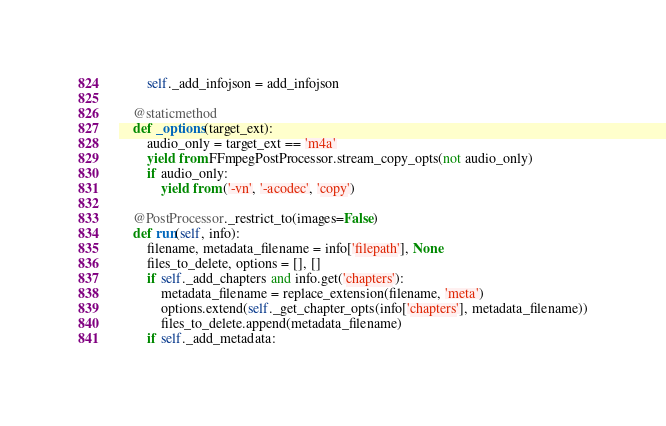Convert code to text. <code><loc_0><loc_0><loc_500><loc_500><_Python_>        self._add_infojson = add_infojson

    @staticmethod
    def _options(target_ext):
        audio_only = target_ext == 'm4a'
        yield from FFmpegPostProcessor.stream_copy_opts(not audio_only)
        if audio_only:
            yield from ('-vn', '-acodec', 'copy')

    @PostProcessor._restrict_to(images=False)
    def run(self, info):
        filename, metadata_filename = info['filepath'], None
        files_to_delete, options = [], []
        if self._add_chapters and info.get('chapters'):
            metadata_filename = replace_extension(filename, 'meta')
            options.extend(self._get_chapter_opts(info['chapters'], metadata_filename))
            files_to_delete.append(metadata_filename)
        if self._add_metadata:</code> 